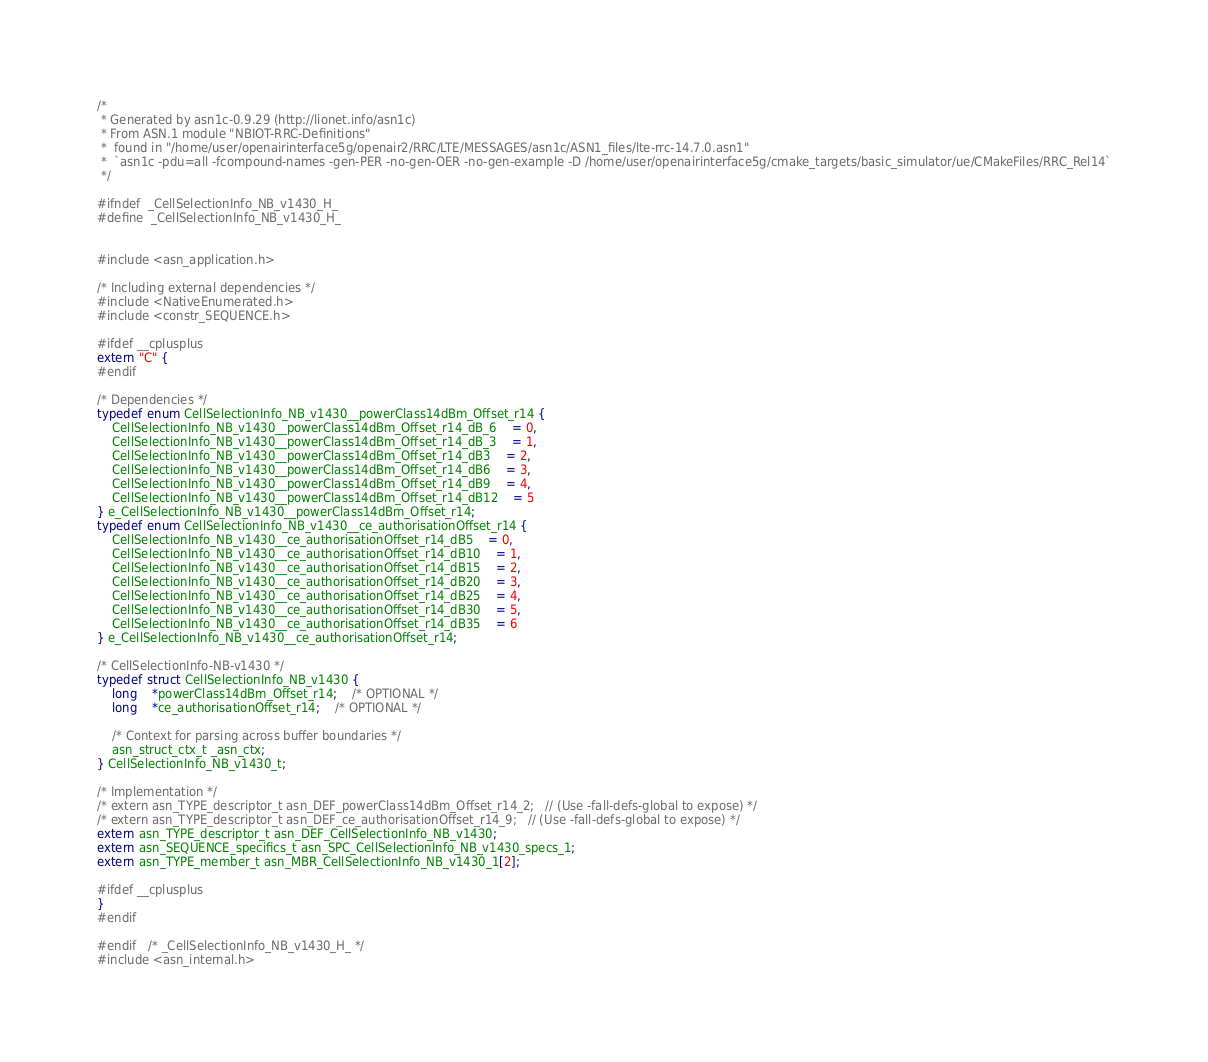<code> <loc_0><loc_0><loc_500><loc_500><_C_>/*
 * Generated by asn1c-0.9.29 (http://lionet.info/asn1c)
 * From ASN.1 module "NBIOT-RRC-Definitions"
 * 	found in "/home/user/openairinterface5g/openair2/RRC/LTE/MESSAGES/asn1c/ASN1_files/lte-rrc-14.7.0.asn1"
 * 	`asn1c -pdu=all -fcompound-names -gen-PER -no-gen-OER -no-gen-example -D /home/user/openairinterface5g/cmake_targets/basic_simulator/ue/CMakeFiles/RRC_Rel14`
 */

#ifndef	_CellSelectionInfo_NB_v1430_H_
#define	_CellSelectionInfo_NB_v1430_H_


#include <asn_application.h>

/* Including external dependencies */
#include <NativeEnumerated.h>
#include <constr_SEQUENCE.h>

#ifdef __cplusplus
extern "C" {
#endif

/* Dependencies */
typedef enum CellSelectionInfo_NB_v1430__powerClass14dBm_Offset_r14 {
	CellSelectionInfo_NB_v1430__powerClass14dBm_Offset_r14_dB_6	= 0,
	CellSelectionInfo_NB_v1430__powerClass14dBm_Offset_r14_dB_3	= 1,
	CellSelectionInfo_NB_v1430__powerClass14dBm_Offset_r14_dB3	= 2,
	CellSelectionInfo_NB_v1430__powerClass14dBm_Offset_r14_dB6	= 3,
	CellSelectionInfo_NB_v1430__powerClass14dBm_Offset_r14_dB9	= 4,
	CellSelectionInfo_NB_v1430__powerClass14dBm_Offset_r14_dB12	= 5
} e_CellSelectionInfo_NB_v1430__powerClass14dBm_Offset_r14;
typedef enum CellSelectionInfo_NB_v1430__ce_authorisationOffset_r14 {
	CellSelectionInfo_NB_v1430__ce_authorisationOffset_r14_dB5	= 0,
	CellSelectionInfo_NB_v1430__ce_authorisationOffset_r14_dB10	= 1,
	CellSelectionInfo_NB_v1430__ce_authorisationOffset_r14_dB15	= 2,
	CellSelectionInfo_NB_v1430__ce_authorisationOffset_r14_dB20	= 3,
	CellSelectionInfo_NB_v1430__ce_authorisationOffset_r14_dB25	= 4,
	CellSelectionInfo_NB_v1430__ce_authorisationOffset_r14_dB30	= 5,
	CellSelectionInfo_NB_v1430__ce_authorisationOffset_r14_dB35	= 6
} e_CellSelectionInfo_NB_v1430__ce_authorisationOffset_r14;

/* CellSelectionInfo-NB-v1430 */
typedef struct CellSelectionInfo_NB_v1430 {
	long	*powerClass14dBm_Offset_r14;	/* OPTIONAL */
	long	*ce_authorisationOffset_r14;	/* OPTIONAL */
	
	/* Context for parsing across buffer boundaries */
	asn_struct_ctx_t _asn_ctx;
} CellSelectionInfo_NB_v1430_t;

/* Implementation */
/* extern asn_TYPE_descriptor_t asn_DEF_powerClass14dBm_Offset_r14_2;	// (Use -fall-defs-global to expose) */
/* extern asn_TYPE_descriptor_t asn_DEF_ce_authorisationOffset_r14_9;	// (Use -fall-defs-global to expose) */
extern asn_TYPE_descriptor_t asn_DEF_CellSelectionInfo_NB_v1430;
extern asn_SEQUENCE_specifics_t asn_SPC_CellSelectionInfo_NB_v1430_specs_1;
extern asn_TYPE_member_t asn_MBR_CellSelectionInfo_NB_v1430_1[2];

#ifdef __cplusplus
}
#endif

#endif	/* _CellSelectionInfo_NB_v1430_H_ */
#include <asn_internal.h>
</code> 